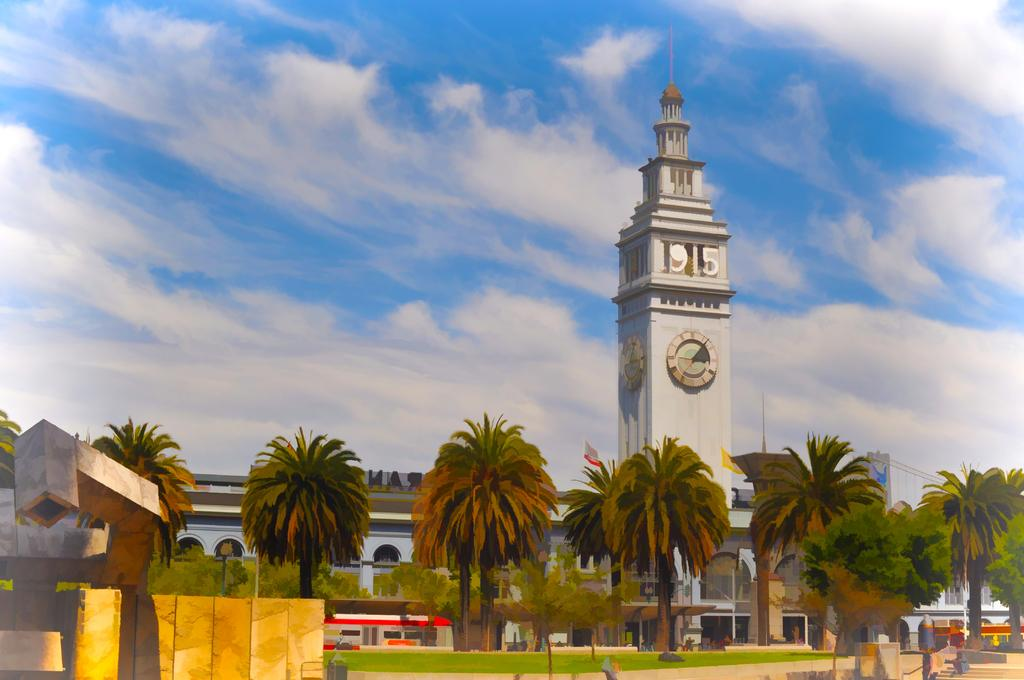What type of artwork is depicted in the image? The image is a painting. What natural elements are present in the painting? There are trees in the painting. What type of structure is featured in the painting? There is a building with a clock tower in the painting. What part of the natural environment is visible in the painting? There is sky visible in the painting. What weather condition can be inferred from the painting? There are clouds in the sky, suggesting a partly cloudy day. What architectural feature is present on the left side of the painting? There is a wall on the left side of the painting. What type of yoke is being used to punish the trees in the painting? There is no yoke or punishment present in the painting; it features trees, a building with a clock tower, and a wall. What color is the punishment in the painting? There is no punishment present in the painting, so it is not possible to determine its color. 